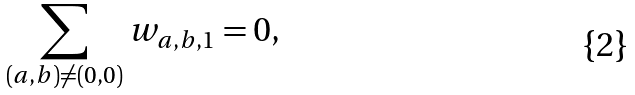<formula> <loc_0><loc_0><loc_500><loc_500>\sum _ { ( a , b ) \neq ( 0 , 0 ) } w _ { a , b , 1 } = 0 ,</formula> 